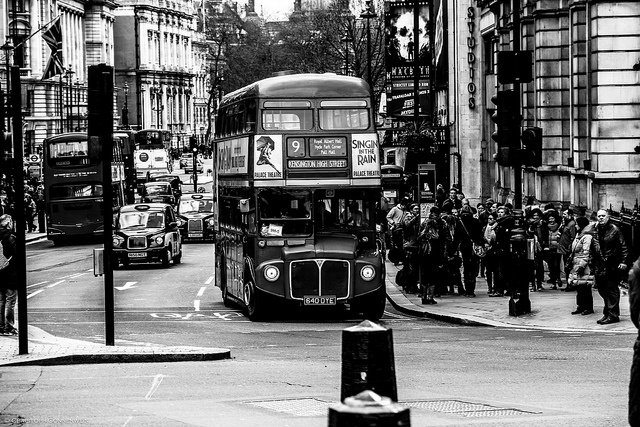Describe the objects in this image and their specific colors. I can see bus in darkgray, black, gray, and lightgray tones, bus in darkgray, black, gray, and lightgray tones, people in darkgray, black, gray, and lightgray tones, car in darkgray, black, lightgray, and gray tones, and people in darkgray, black, gray, and lightgray tones in this image. 